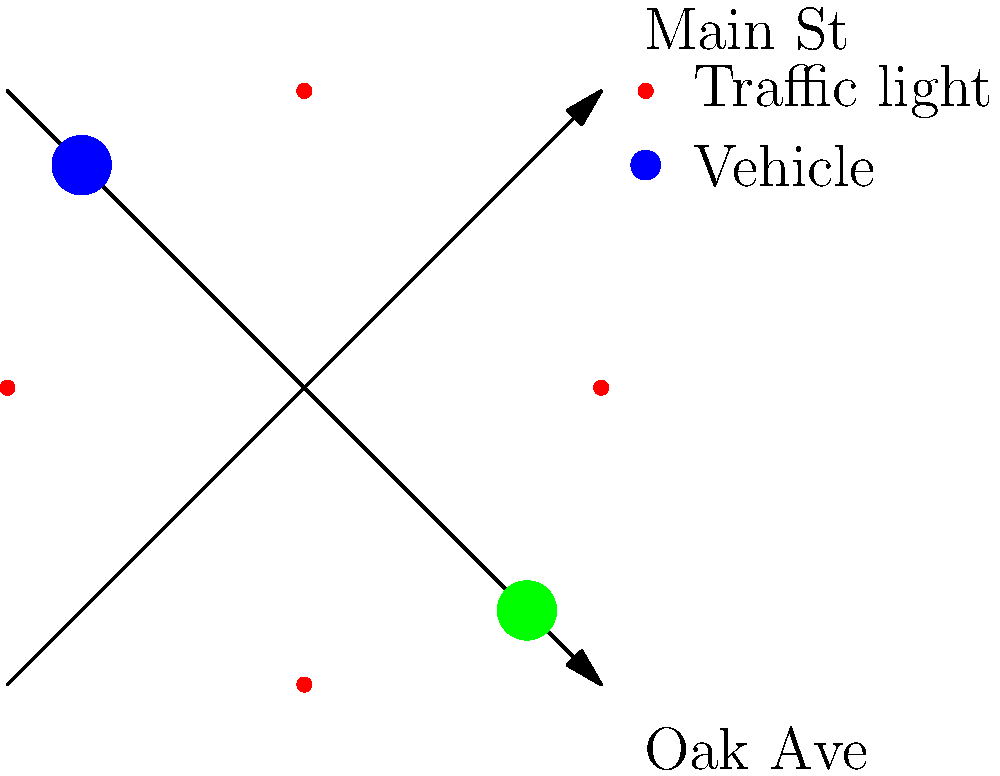At a busy intersection where a tragic accident occurred, city planners are considering implementing an adaptive traffic signal system. Given that the average vehicle speed approaching the intersection is 40 km/h and the reaction time of drivers is typically 1.5 seconds, what is the minimum safe distance (in meters) from the intersection at which the traffic signal should change to yellow to allow vehicles to stop safely? To determine the minimum safe distance for the traffic signal to change, we need to consider both the reaction distance and the braking distance. Let's break this down step-by-step:

1. Convert the speed from km/h to m/s:
   $40 \text{ km/h} = 40 \times \frac{1000 \text{ m}}{3600 \text{ s}} = 11.11 \text{ m/s}$

2. Calculate the reaction distance:
   Reaction distance = Speed × Reaction time
   $d_r = 11.11 \text{ m/s} \times 1.5 \text{ s} = 16.67 \text{ m}$

3. Calculate the braking distance:
   We'll use the equation: $d_b = \frac{v^2}{2\mu g}$
   Where:
   $v$ is the initial velocity (11.11 m/s)
   $\mu$ is the coefficient of friction (assume 0.7 for dry pavement)
   $g$ is the acceleration due to gravity (9.81 m/s²)

   $d_b = \frac{(11.11 \text{ m/s})^2}{2 \times 0.7 \times 9.81 \text{ m/s}^2} = 9.04 \text{ m}$

4. The total stopping distance is the sum of the reaction distance and braking distance:
   $d_{total} = d_r + d_b = 16.67 \text{ m} + 9.04 \text{ m} = 25.71 \text{ m}$

Therefore, the minimum safe distance from the intersection at which the traffic signal should change to yellow is approximately 25.71 meters.
Answer: 25.71 meters 